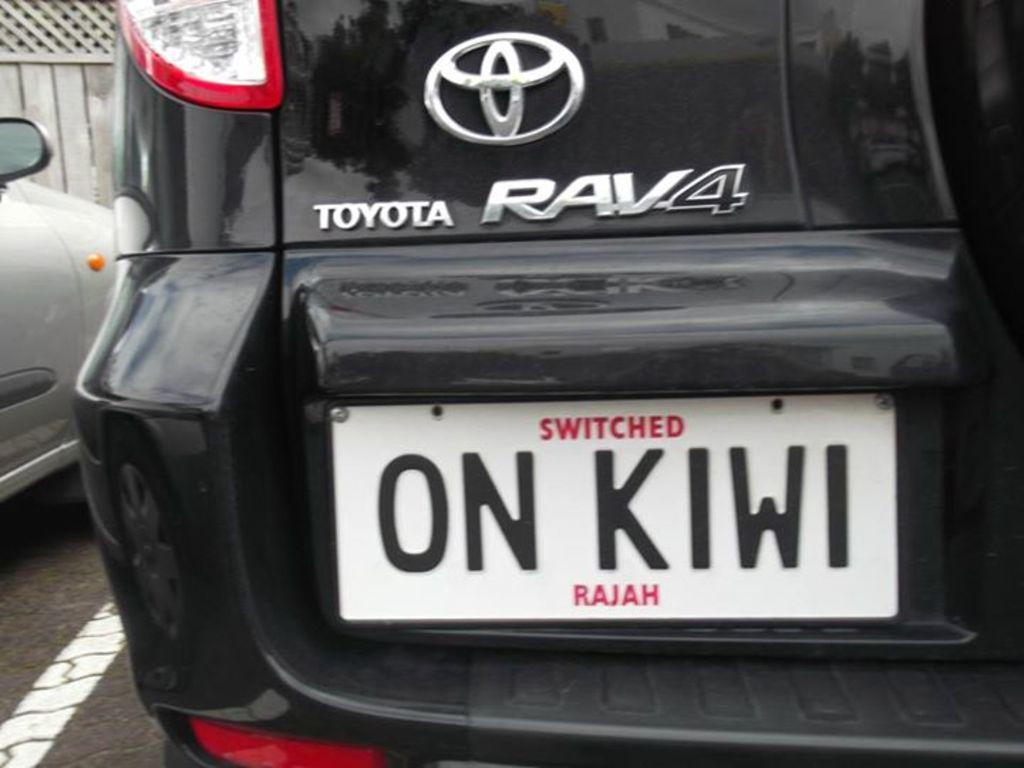<image>
Describe the image concisely. Black RAV4 with the license plate which says "ON KIWI". 